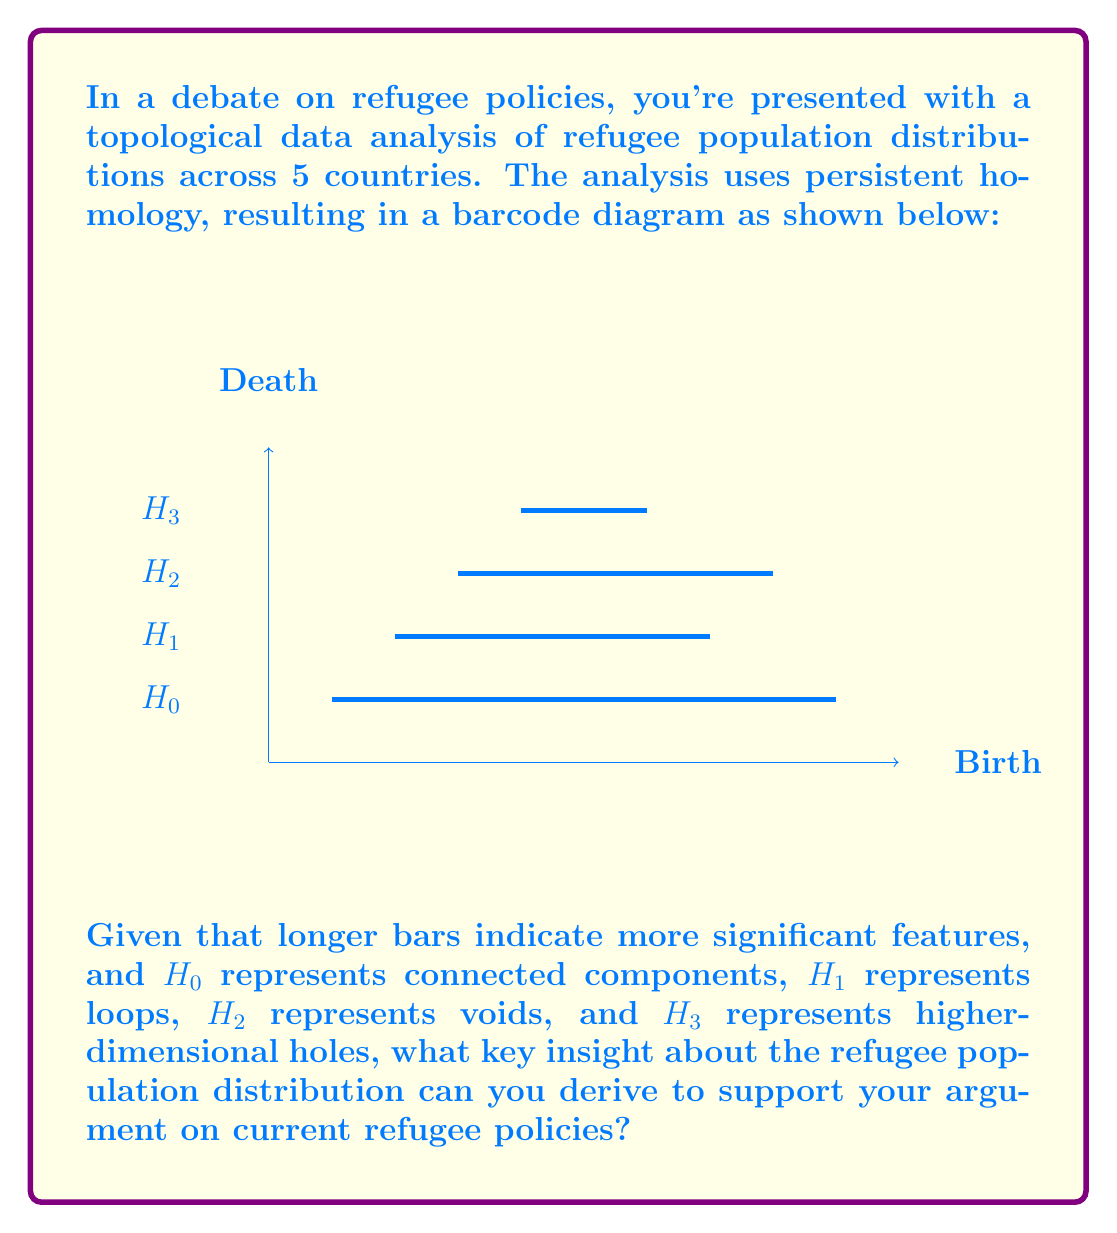Teach me how to tackle this problem. To answer this question, we need to interpret the barcode diagram in the context of refugee population distribution:

1. Analyze $H_0$ (connected components):
   The $H_0$ bar is the longest, spanning from 1 to 9 on the Birth-Death axis. This indicates that there are distinct, separate clusters of refugee populations that persist across a wide range of parameter values.

2. Examine $H_1$ (loops):
   The $H_1$ bar is the second longest, spanning from 2 to 7. This suggests the presence of circular or loop-like structures in the data, possibly indicating interconnected refugee communities or circular migration patterns.

3. Look at $H_2$ (voids):
   The $H_2$ bar spans from 3 to 8, indicating the presence of three-dimensional voids or cavities in the data structure. This could represent gaps in refugee distribution or areas with lower refugee density surrounded by higher density regions.

4. Consider $H_3$ (higher-dimensional holes):
   The $H_3$ bar is the shortest, spanning from 4 to 6. This suggests some higher-dimensional structure, but it's less prominent than the lower-dimensional features.

5. Interpret the results:
   The persistence of $H_0$ indicates that refugee populations are distinctly clustered, possibly in separate countries or regions. The significant $H_1$ and $H_2$ features suggest complex interactions and distributions within these clusters.

6. Relate to refugee policies:
   This topological analysis reveals that current refugee distributions are not uniform or randomly distributed. Instead, they form distinct, interconnected clusters with internal structure. This suggests that refugee policies may need to account for these natural groupings and interactions rather than treating refugee populations as homogeneous.
Answer: Refugee populations form distinct, persistent clusters with complex internal structures, suggesting policies should address group dynamics rather than treating refugees as a uniform population. 